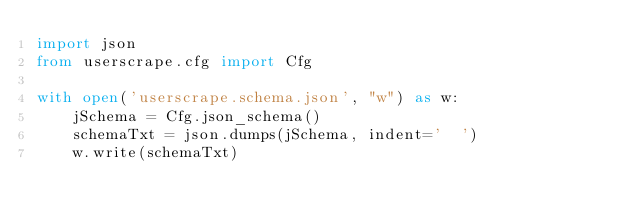Convert code to text. <code><loc_0><loc_0><loc_500><loc_500><_Python_>import json
from userscrape.cfg import Cfg

with open('userscrape.schema.json', "w") as w:
    jSchema = Cfg.json_schema()
    schemaTxt = json.dumps(jSchema, indent='  ')
    w.write(schemaTxt)
</code> 